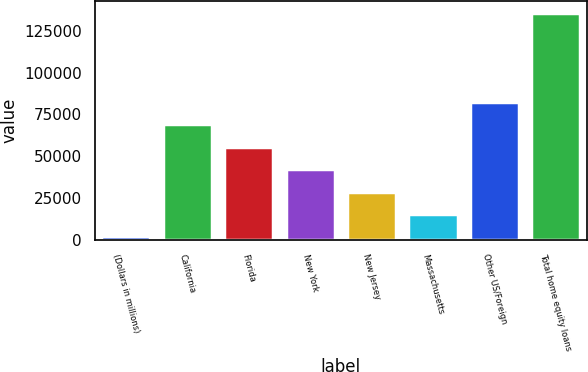Convert chart to OTSL. <chart><loc_0><loc_0><loc_500><loc_500><bar_chart><fcel>(Dollars in millions)<fcel>California<fcel>Florida<fcel>New York<fcel>New Jersey<fcel>Massachusetts<fcel>Other US/Foreign<fcel>Total home equity loans<nl><fcel>2009<fcel>68960.5<fcel>55570.2<fcel>42179.9<fcel>28789.6<fcel>15399.3<fcel>82350.8<fcel>135912<nl></chart> 